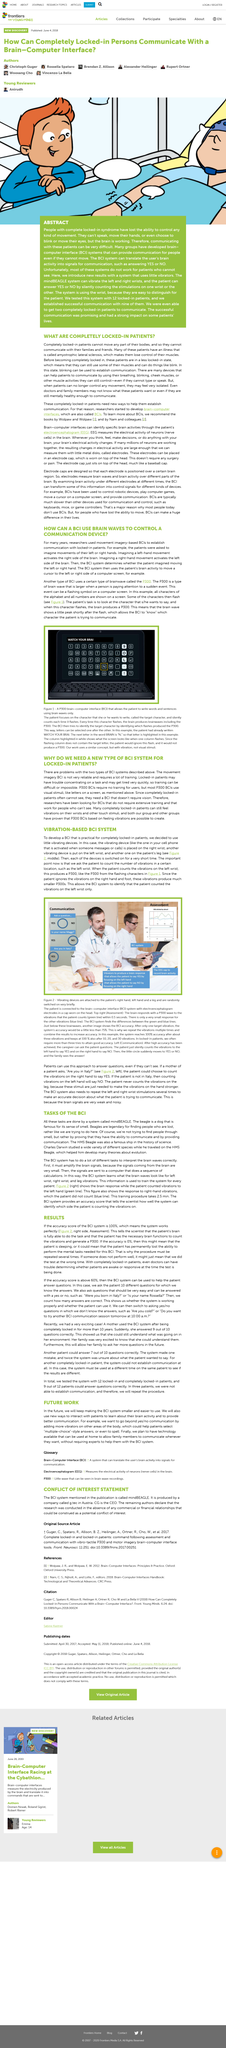Highlight a few significant elements in this photo. Yes, a BCI (Brain-Computer Interface) system uses brainwaves to control a cursor on a screen. The fact is that a right-hand movement does not activate the right side of the brain, but rather the left side of the brain. Yes, imagery-based BCIs can establish communication with locked-in patients. It is important to note that the accuracy of the test should be evaluated on multiple occasions in order to ensure reliable results. A single, potentially inaccurate test result may indicate that the test was performed at an inappropriate time, highlighting the importance of careful timing and consideration. The company seeks to revolutionize the interaction with patients by introducing innovative methods of communication, such as adding more vibrators to stimulate other areas of the body, which will enable patients to select multiple choice answers and potentially even spell out their choices. 